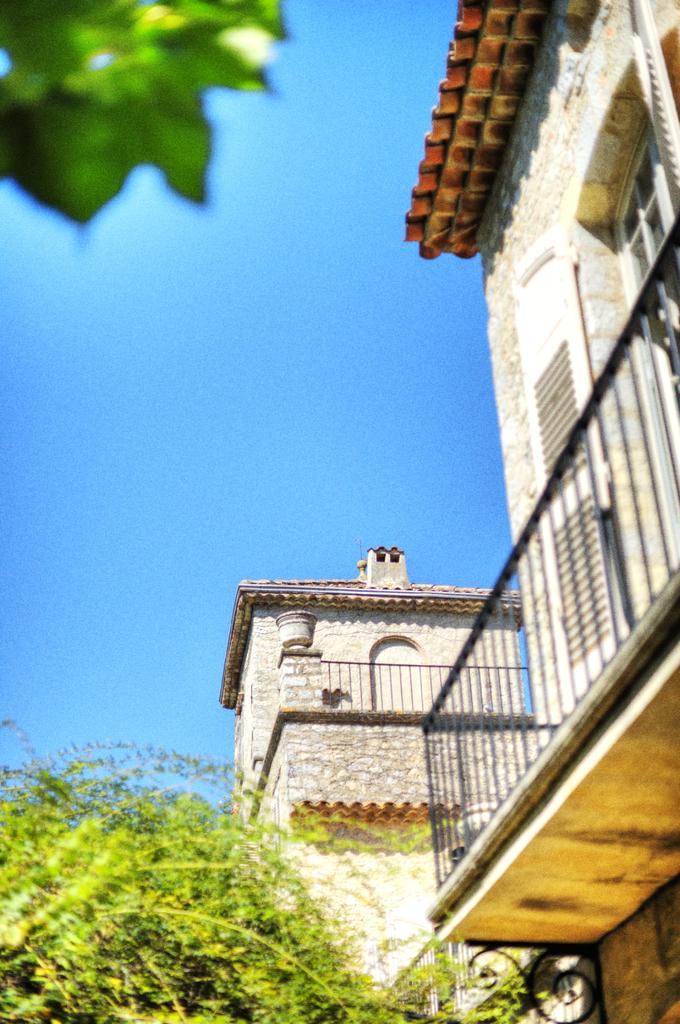In one or two sentences, can you explain what this image depicts? In this image there are buildings and trees. In the background there is sky. 